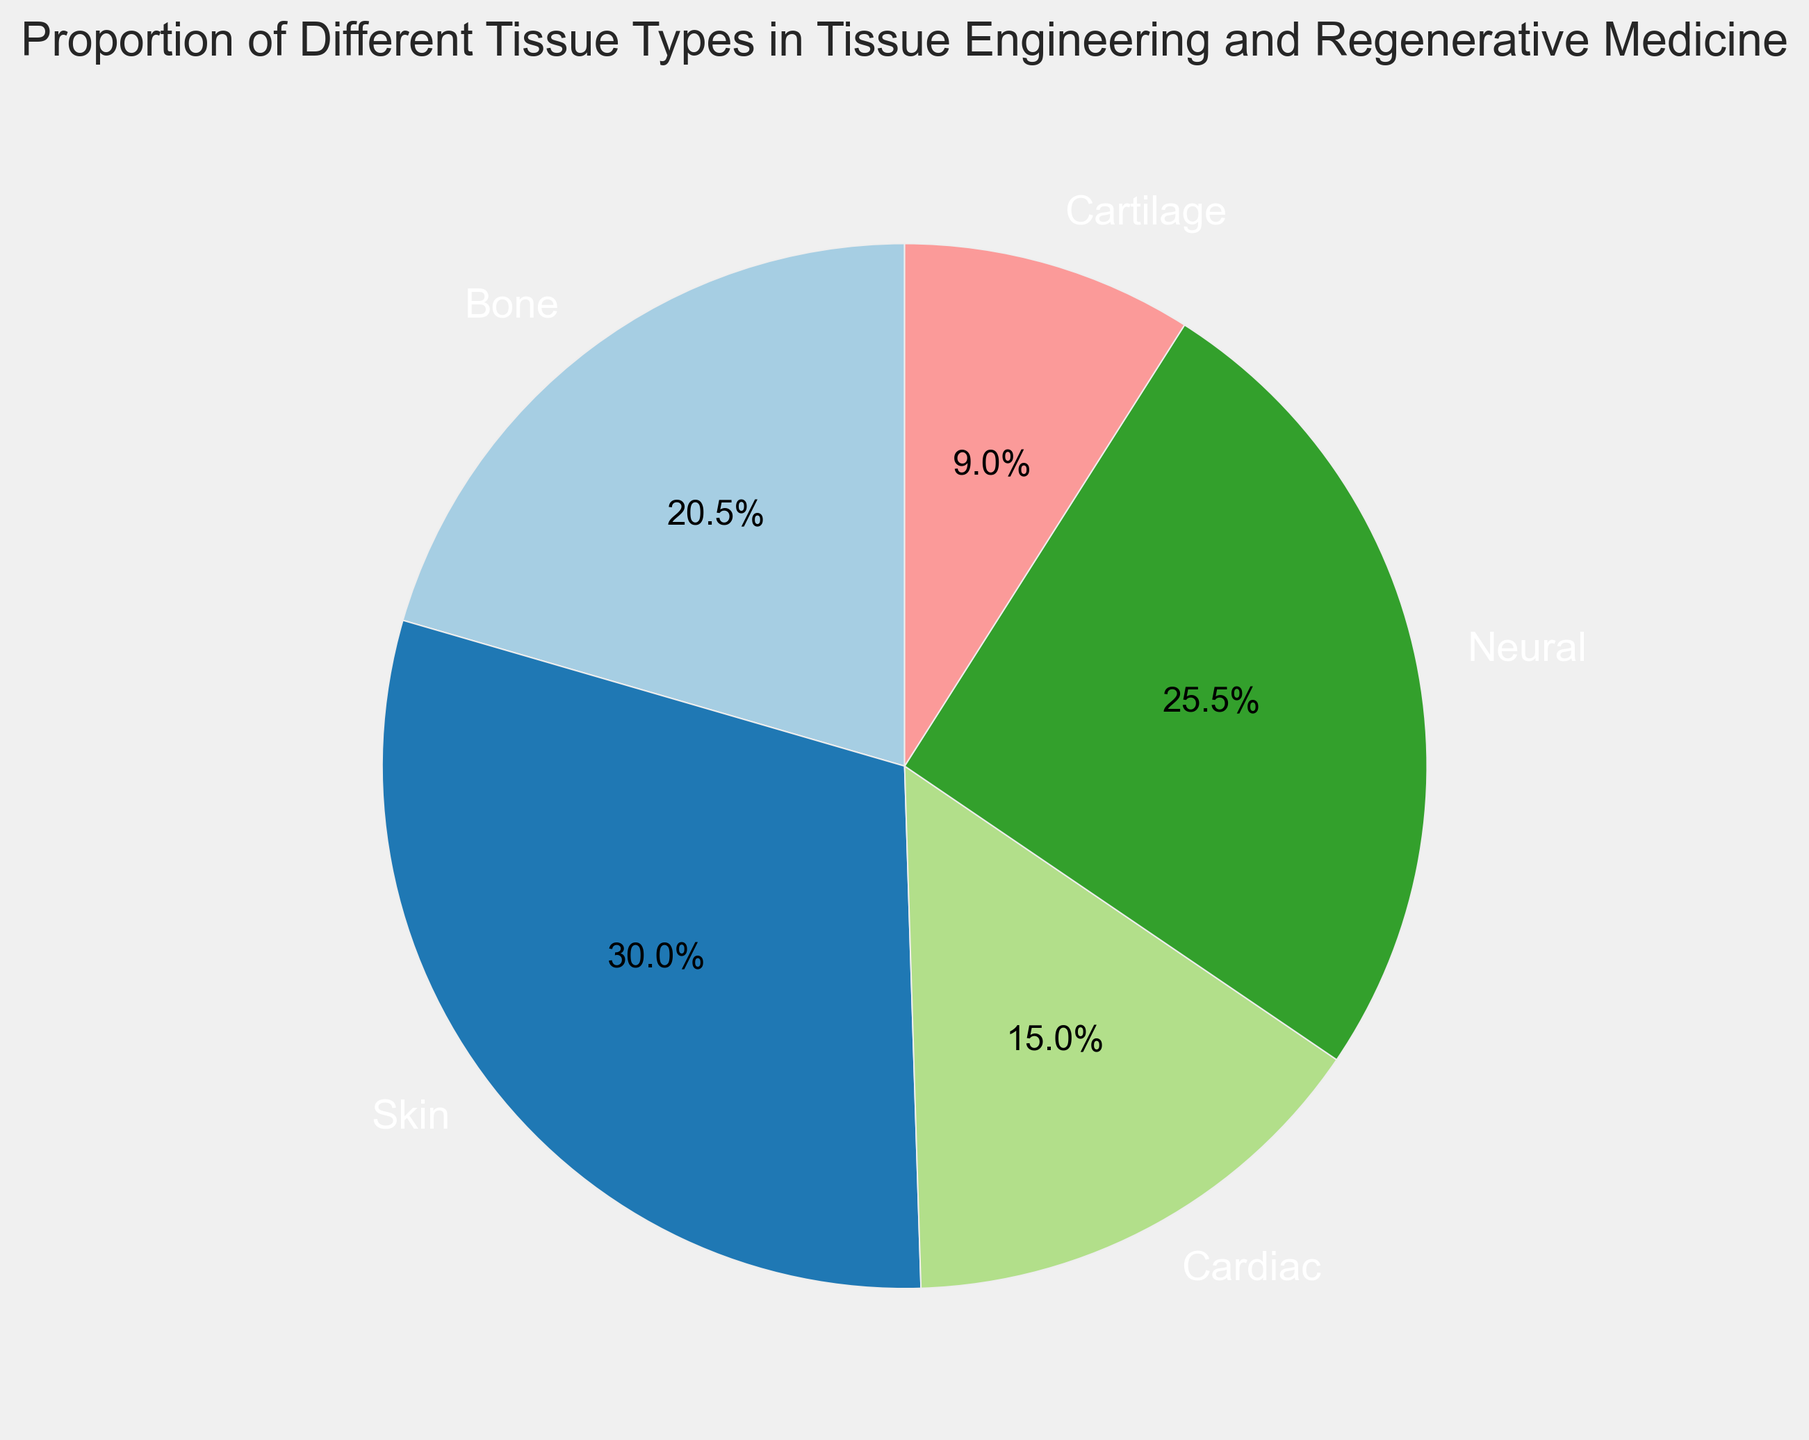What is the largest tissue type proportion in the chart? By examining the pie chart, the largest proportion can be identified by the size of the corresponding pie slice. The slice for Skin is the largest, indicating that it has the highest proportion.
Answer: Skin What is the proportion of Bone tissue? According to the labels on the pie chart, the proportion of Bone tissue can be directly read.
Answer: 20.5% Which tissues have a proportion greater than Cardiac tissue? The chart shows that Skin and Neural tissues both have a larger corresponding slice than Cardiac. Therefore, they have a higher proportion.
Answer: Skin and Neural What's the total proportion of Cardiac, Neural, and Bone tissues combined? To find the combined proportion, sum the individual proportions: 15.0 (Cardiac) + 25.5 (Neural) + 20.5 (Bone) = 61.0%.
Answer: 61.0% Identify the tissue type with the smallest proportion and mention its value. The pie chart shows that the smallest slice corresponds to Cartilage, which has the smallest proportion.
Answer: Cartilage, 9.0% How much more is the proportion of Skin compared to Cartilage? To determine this, subtract the proportion of Cartilage from that of Skin: 30.0 (Skin) - 9.0 (Cartilage) = 21.0%.
Answer: 21.0% Is the proportion of Neural tissue greater than or less than the combined proportion of Bone and Cartilage? Add the proportions of Bone and Cartilage: 20.5 (Bone) + 9.0 (Cartilage) = 29.5%. Comparing this with Neural (25.5%) shows that Neural is less than the combined Bone and Cartilage proportion.
Answer: Less than Which tissue types together make up half (50%) of the total proportion in the chart? By adding proportions stepwise, we see: Skin (30.0%) + Neural (25.5%) = 55.5%. Therefore, Skin alone is 30.0% and adding 25.5% from Neural exceeds 50%. No combination exactly makes 50%, but Skin and Neural are the closest when summed.
Answer: Skin and Neural (55.5%) What percentage of the total pie chart is not made up of Skin and Neural tissues? Subtract the combined proportion of Skin and Neural from 100%: 100 - (30.0 + 25.5) = 100 - 55.5 = 44.5%.
Answer: 44.5% What is the average proportion of all the tissue types? Sum all the proportions and divide by the number of tissue types: (20.5 + 30.0 + 15.0 + 25.5 + 9.0) / 5 = 100 / 5 = 20.0%.
Answer: 20.0% 